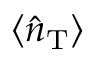<formula> <loc_0><loc_0><loc_500><loc_500>\langle \hat { n } _ { T } \rangle</formula> 